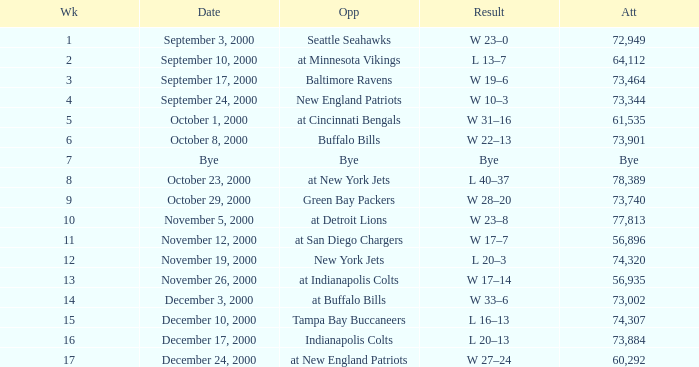What is the Result of the game with 72,949 in attendance? W 23–0. 